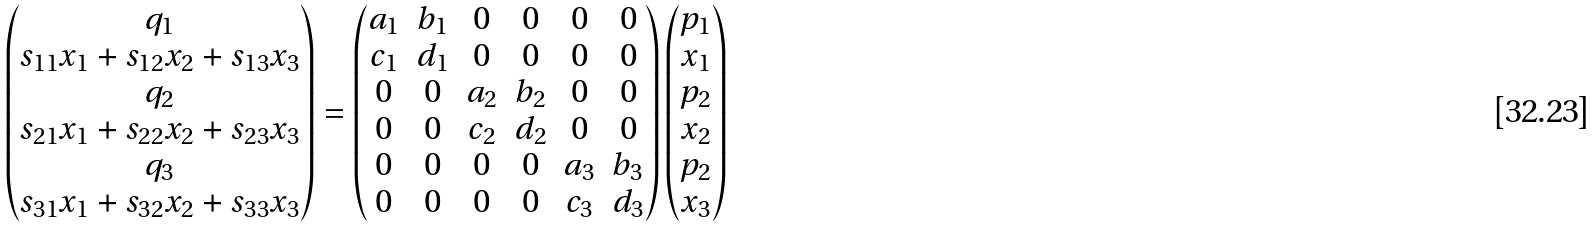Convert formula to latex. <formula><loc_0><loc_0><loc_500><loc_500>\begin{pmatrix} q _ { 1 } \\ s _ { 1 1 } x _ { 1 } + s _ { 1 2 } x _ { 2 } + s _ { 1 3 } x _ { 3 } \\ q _ { 2 } \\ s _ { 2 1 } x _ { 1 } + s _ { 2 2 } x _ { 2 } + s _ { 2 3 } x _ { 3 } \\ q _ { 3 } \\ s _ { 3 1 } x _ { 1 } + s _ { 3 2 } x _ { 2 } + s _ { 3 3 } x _ { 3 } \end{pmatrix} = \begin{pmatrix} a _ { 1 } & b _ { 1 } & 0 & 0 & 0 & 0 \\ c _ { 1 } & d _ { 1 } & 0 & 0 & 0 & 0 \\ 0 & 0 & a _ { 2 } & b _ { 2 } & 0 & 0 \\ 0 & 0 & c _ { 2 } & d _ { 2 } & 0 & 0 \\ 0 & 0 & 0 & 0 & a _ { 3 } & b _ { 3 } \\ 0 & 0 & 0 & 0 & c _ { 3 } & d _ { 3 } \end{pmatrix} \begin{pmatrix} p _ { 1 } \\ x _ { 1 } \\ p _ { 2 } \\ x _ { 2 } \\ p _ { 2 } \\ x _ { 3 } \end{pmatrix}</formula> 